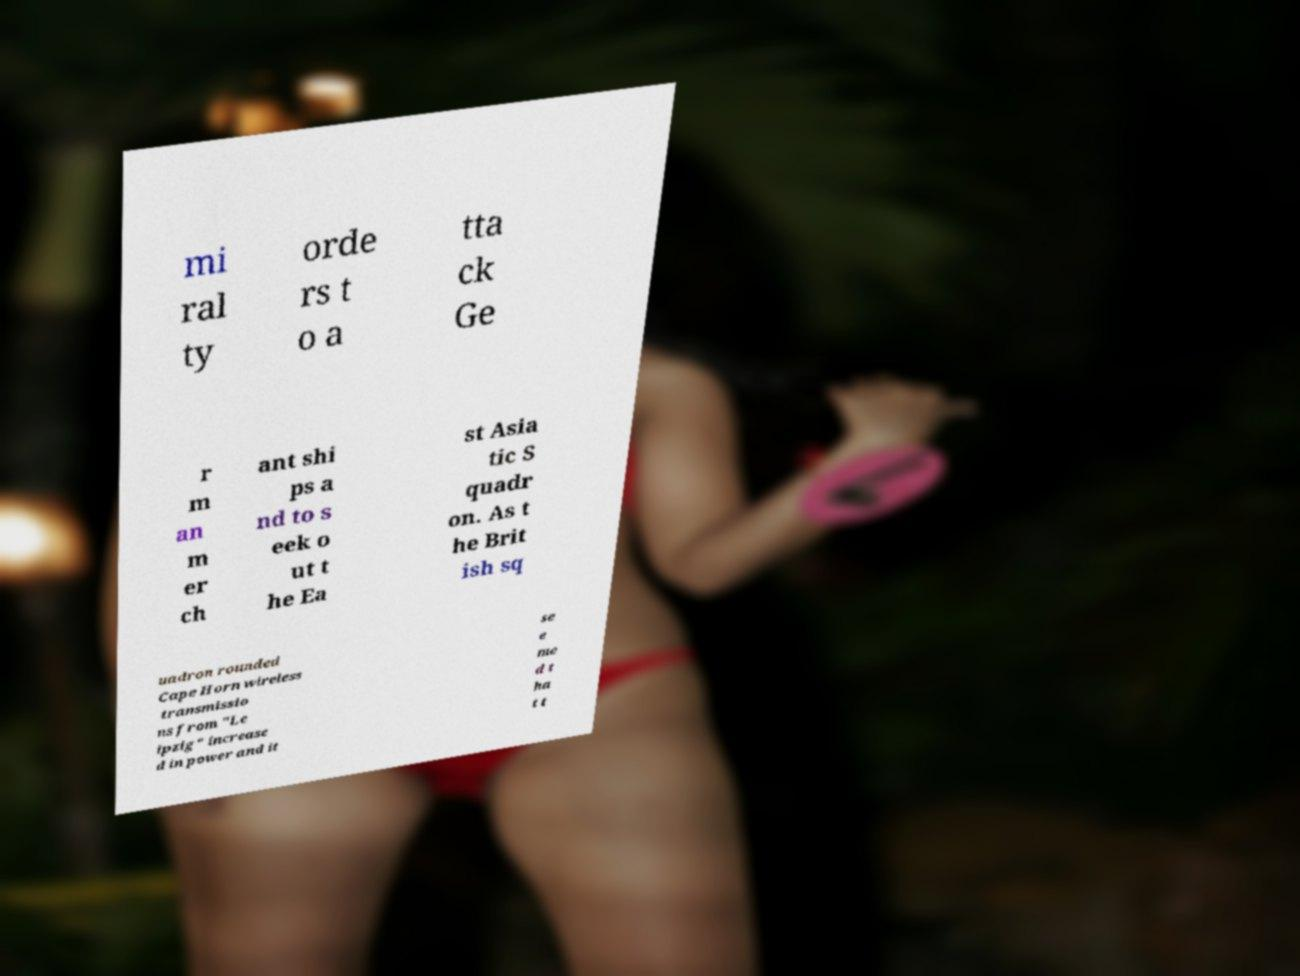There's text embedded in this image that I need extracted. Can you transcribe it verbatim? mi ral ty orde rs t o a tta ck Ge r m an m er ch ant shi ps a nd to s eek o ut t he Ea st Asia tic S quadr on. As t he Brit ish sq uadron rounded Cape Horn wireless transmissio ns from "Le ipzig" increase d in power and it se e me d t ha t t 